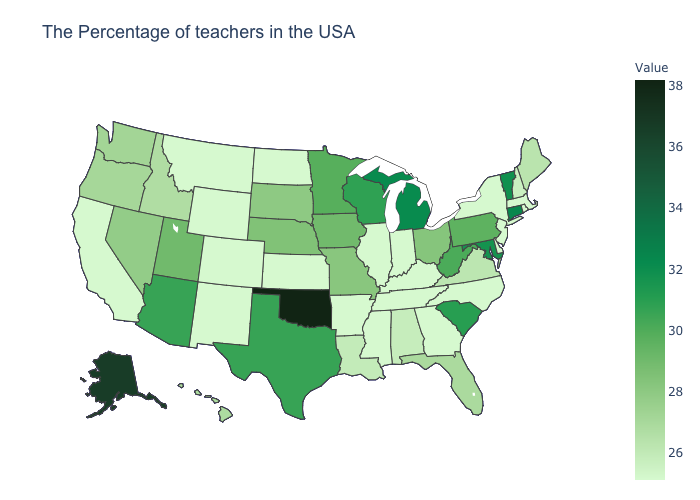Among the states that border Mississippi , does Alabama have the lowest value?
Keep it brief. No. 